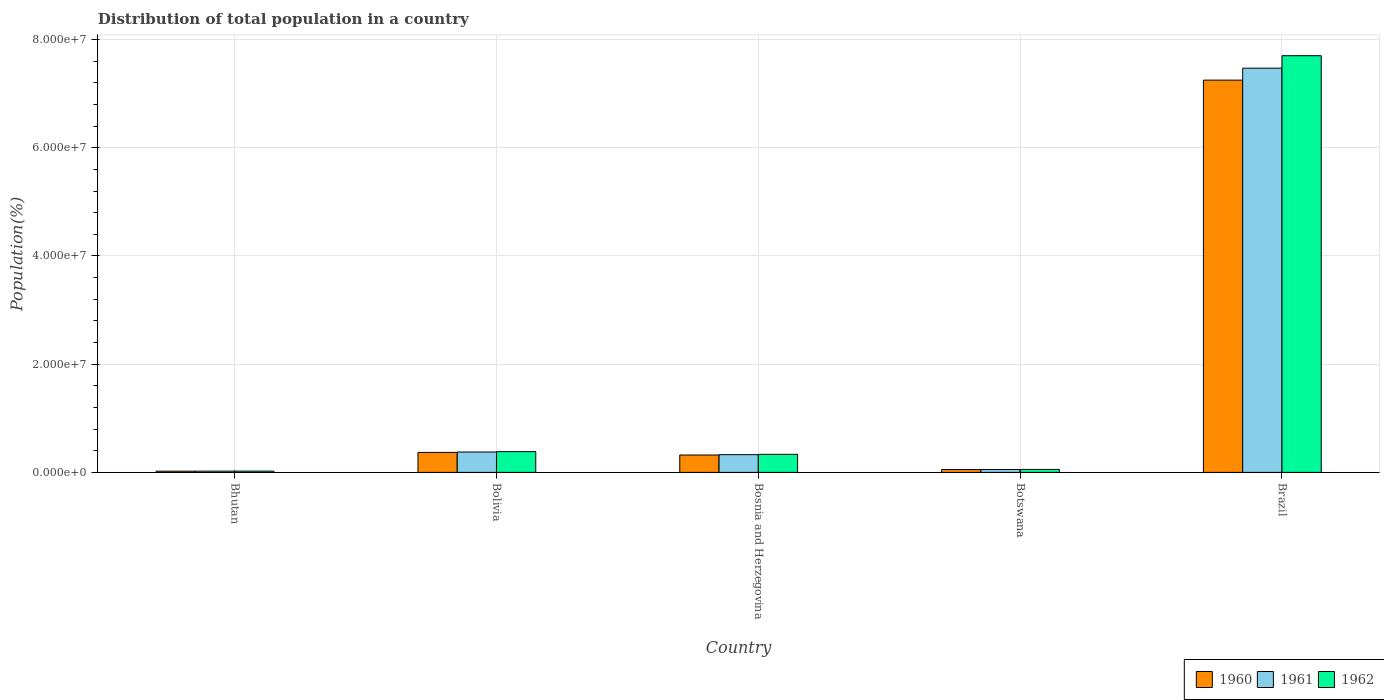How many groups of bars are there?
Provide a short and direct response. 5. What is the label of the 1st group of bars from the left?
Offer a very short reply. Bhutan. In how many cases, is the number of bars for a given country not equal to the number of legend labels?
Provide a succinct answer. 0. What is the population of in 1962 in Botswana?
Make the answer very short. 5.50e+05. Across all countries, what is the maximum population of in 1960?
Your answer should be very brief. 7.25e+07. Across all countries, what is the minimum population of in 1961?
Your answer should be compact. 2.29e+05. In which country was the population of in 1961 minimum?
Give a very brief answer. Bhutan. What is the total population of in 1960 in the graph?
Offer a very short reply. 8.01e+07. What is the difference between the population of in 1961 in Bosnia and Herzegovina and that in Botswana?
Your answer should be very brief. 2.74e+06. What is the difference between the population of in 1961 in Brazil and the population of in 1962 in Botswana?
Give a very brief answer. 7.42e+07. What is the average population of in 1961 per country?
Provide a succinct answer. 1.65e+07. What is the difference between the population of of/in 1962 and population of of/in 1961 in Bhutan?
Provide a succinct answer. 5406. In how many countries, is the population of in 1961 greater than 8000000 %?
Your answer should be very brief. 1. What is the ratio of the population of in 1960 in Bolivia to that in Brazil?
Your response must be concise. 0.05. Is the difference between the population of in 1962 in Bhutan and Bolivia greater than the difference between the population of in 1961 in Bhutan and Bolivia?
Your response must be concise. No. What is the difference between the highest and the second highest population of in 1961?
Your answer should be compact. 7.14e+07. What is the difference between the highest and the lowest population of in 1960?
Your answer should be compact. 7.23e+07. In how many countries, is the population of in 1962 greater than the average population of in 1962 taken over all countries?
Provide a succinct answer. 1. What does the 1st bar from the right in Bolivia represents?
Give a very brief answer. 1962. What is the difference between two consecutive major ticks on the Y-axis?
Provide a succinct answer. 2.00e+07. Are the values on the major ticks of Y-axis written in scientific E-notation?
Provide a short and direct response. Yes. How are the legend labels stacked?
Ensure brevity in your answer.  Horizontal. What is the title of the graph?
Offer a very short reply. Distribution of total population in a country. Does "1960" appear as one of the legend labels in the graph?
Offer a very short reply. Yes. What is the label or title of the Y-axis?
Give a very brief answer. Population(%). What is the Population(%) in 1960 in Bhutan?
Your answer should be compact. 2.24e+05. What is the Population(%) of 1961 in Bhutan?
Your response must be concise. 2.29e+05. What is the Population(%) in 1962 in Bhutan?
Your answer should be compact. 2.35e+05. What is the Population(%) of 1960 in Bolivia?
Provide a short and direct response. 3.69e+06. What is the Population(%) in 1961 in Bolivia?
Your answer should be compact. 3.76e+06. What is the Population(%) of 1962 in Bolivia?
Your answer should be compact. 3.84e+06. What is the Population(%) in 1960 in Bosnia and Herzegovina?
Your answer should be very brief. 3.21e+06. What is the Population(%) in 1961 in Bosnia and Herzegovina?
Offer a terse response. 3.28e+06. What is the Population(%) in 1962 in Bosnia and Herzegovina?
Keep it short and to the point. 3.34e+06. What is the Population(%) of 1960 in Botswana?
Your response must be concise. 5.24e+05. What is the Population(%) of 1961 in Botswana?
Give a very brief answer. 5.37e+05. What is the Population(%) in 1962 in Botswana?
Offer a terse response. 5.50e+05. What is the Population(%) in 1960 in Brazil?
Your response must be concise. 7.25e+07. What is the Population(%) in 1961 in Brazil?
Provide a short and direct response. 7.47e+07. What is the Population(%) in 1962 in Brazil?
Make the answer very short. 7.70e+07. Across all countries, what is the maximum Population(%) in 1960?
Offer a very short reply. 7.25e+07. Across all countries, what is the maximum Population(%) in 1961?
Give a very brief answer. 7.47e+07. Across all countries, what is the maximum Population(%) in 1962?
Make the answer very short. 7.70e+07. Across all countries, what is the minimum Population(%) in 1960?
Offer a very short reply. 2.24e+05. Across all countries, what is the minimum Population(%) of 1961?
Ensure brevity in your answer.  2.29e+05. Across all countries, what is the minimum Population(%) in 1962?
Provide a succinct answer. 2.35e+05. What is the total Population(%) in 1960 in the graph?
Make the answer very short. 8.01e+07. What is the total Population(%) in 1961 in the graph?
Offer a very short reply. 8.25e+07. What is the total Population(%) in 1962 in the graph?
Offer a terse response. 8.50e+07. What is the difference between the Population(%) of 1960 in Bhutan and that in Bolivia?
Keep it short and to the point. -3.47e+06. What is the difference between the Population(%) of 1961 in Bhutan and that in Bolivia?
Offer a terse response. -3.54e+06. What is the difference between the Population(%) in 1962 in Bhutan and that in Bolivia?
Your answer should be compact. -3.60e+06. What is the difference between the Population(%) of 1960 in Bhutan and that in Bosnia and Herzegovina?
Provide a short and direct response. -2.99e+06. What is the difference between the Population(%) in 1961 in Bhutan and that in Bosnia and Herzegovina?
Offer a terse response. -3.05e+06. What is the difference between the Population(%) of 1962 in Bhutan and that in Bosnia and Herzegovina?
Keep it short and to the point. -3.11e+06. What is the difference between the Population(%) of 1960 in Bhutan and that in Botswana?
Offer a very short reply. -3.00e+05. What is the difference between the Population(%) in 1961 in Bhutan and that in Botswana?
Offer a very short reply. -3.07e+05. What is the difference between the Population(%) in 1962 in Bhutan and that in Botswana?
Your answer should be compact. -3.15e+05. What is the difference between the Population(%) of 1960 in Bhutan and that in Brazil?
Your answer should be very brief. -7.23e+07. What is the difference between the Population(%) in 1961 in Bhutan and that in Brazil?
Keep it short and to the point. -7.45e+07. What is the difference between the Population(%) in 1962 in Bhutan and that in Brazil?
Offer a very short reply. -7.68e+07. What is the difference between the Population(%) in 1960 in Bolivia and that in Bosnia and Herzegovina?
Provide a succinct answer. 4.79e+05. What is the difference between the Population(%) of 1961 in Bolivia and that in Bosnia and Herzegovina?
Your response must be concise. 4.88e+05. What is the difference between the Population(%) of 1962 in Bolivia and that in Bosnia and Herzegovina?
Provide a short and direct response. 4.96e+05. What is the difference between the Population(%) of 1960 in Bolivia and that in Botswana?
Offer a terse response. 3.17e+06. What is the difference between the Population(%) of 1961 in Bolivia and that in Botswana?
Provide a succinct answer. 3.23e+06. What is the difference between the Population(%) of 1962 in Bolivia and that in Botswana?
Your answer should be very brief. 3.29e+06. What is the difference between the Population(%) of 1960 in Bolivia and that in Brazil?
Keep it short and to the point. -6.88e+07. What is the difference between the Population(%) in 1961 in Bolivia and that in Brazil?
Your answer should be compact. -7.09e+07. What is the difference between the Population(%) in 1962 in Bolivia and that in Brazil?
Give a very brief answer. -7.32e+07. What is the difference between the Population(%) in 1960 in Bosnia and Herzegovina and that in Botswana?
Offer a terse response. 2.69e+06. What is the difference between the Population(%) in 1961 in Bosnia and Herzegovina and that in Botswana?
Provide a short and direct response. 2.74e+06. What is the difference between the Population(%) in 1962 in Bosnia and Herzegovina and that in Botswana?
Make the answer very short. 2.79e+06. What is the difference between the Population(%) in 1960 in Bosnia and Herzegovina and that in Brazil?
Your answer should be compact. -6.93e+07. What is the difference between the Population(%) of 1961 in Bosnia and Herzegovina and that in Brazil?
Offer a terse response. -7.14e+07. What is the difference between the Population(%) in 1962 in Bosnia and Herzegovina and that in Brazil?
Provide a succinct answer. -7.37e+07. What is the difference between the Population(%) in 1960 in Botswana and that in Brazil?
Give a very brief answer. -7.20e+07. What is the difference between the Population(%) in 1961 in Botswana and that in Brazil?
Offer a very short reply. -7.42e+07. What is the difference between the Population(%) of 1962 in Botswana and that in Brazil?
Ensure brevity in your answer.  -7.65e+07. What is the difference between the Population(%) in 1960 in Bhutan and the Population(%) in 1961 in Bolivia?
Your answer should be very brief. -3.54e+06. What is the difference between the Population(%) in 1960 in Bhutan and the Population(%) in 1962 in Bolivia?
Offer a terse response. -3.61e+06. What is the difference between the Population(%) in 1961 in Bhutan and the Population(%) in 1962 in Bolivia?
Your answer should be very brief. -3.61e+06. What is the difference between the Population(%) in 1960 in Bhutan and the Population(%) in 1961 in Bosnia and Herzegovina?
Offer a terse response. -3.05e+06. What is the difference between the Population(%) of 1960 in Bhutan and the Population(%) of 1962 in Bosnia and Herzegovina?
Make the answer very short. -3.12e+06. What is the difference between the Population(%) in 1961 in Bhutan and the Population(%) in 1962 in Bosnia and Herzegovina?
Provide a succinct answer. -3.11e+06. What is the difference between the Population(%) of 1960 in Bhutan and the Population(%) of 1961 in Botswana?
Offer a very short reply. -3.12e+05. What is the difference between the Population(%) of 1960 in Bhutan and the Population(%) of 1962 in Botswana?
Offer a terse response. -3.26e+05. What is the difference between the Population(%) of 1961 in Bhutan and the Population(%) of 1962 in Botswana?
Offer a terse response. -3.21e+05. What is the difference between the Population(%) of 1960 in Bhutan and the Population(%) of 1961 in Brazil?
Give a very brief answer. -7.45e+07. What is the difference between the Population(%) of 1960 in Bhutan and the Population(%) of 1962 in Brazil?
Offer a terse response. -7.68e+07. What is the difference between the Population(%) of 1961 in Bhutan and the Population(%) of 1962 in Brazil?
Provide a short and direct response. -7.68e+07. What is the difference between the Population(%) of 1960 in Bolivia and the Population(%) of 1961 in Bosnia and Herzegovina?
Make the answer very short. 4.16e+05. What is the difference between the Population(%) in 1960 in Bolivia and the Population(%) in 1962 in Bosnia and Herzegovina?
Your answer should be very brief. 3.52e+05. What is the difference between the Population(%) of 1961 in Bolivia and the Population(%) of 1962 in Bosnia and Herzegovina?
Provide a succinct answer. 4.23e+05. What is the difference between the Population(%) in 1960 in Bolivia and the Population(%) in 1961 in Botswana?
Provide a succinct answer. 3.16e+06. What is the difference between the Population(%) in 1960 in Bolivia and the Population(%) in 1962 in Botswana?
Your response must be concise. 3.14e+06. What is the difference between the Population(%) in 1961 in Bolivia and the Population(%) in 1962 in Botswana?
Provide a short and direct response. 3.21e+06. What is the difference between the Population(%) in 1960 in Bolivia and the Population(%) in 1961 in Brazil?
Make the answer very short. -7.10e+07. What is the difference between the Population(%) in 1960 in Bolivia and the Population(%) in 1962 in Brazil?
Offer a terse response. -7.33e+07. What is the difference between the Population(%) in 1961 in Bolivia and the Population(%) in 1962 in Brazil?
Your answer should be very brief. -7.32e+07. What is the difference between the Population(%) in 1960 in Bosnia and Herzegovina and the Population(%) in 1961 in Botswana?
Your answer should be compact. 2.68e+06. What is the difference between the Population(%) in 1960 in Bosnia and Herzegovina and the Population(%) in 1962 in Botswana?
Offer a terse response. 2.66e+06. What is the difference between the Population(%) in 1961 in Bosnia and Herzegovina and the Population(%) in 1962 in Botswana?
Your response must be concise. 2.73e+06. What is the difference between the Population(%) in 1960 in Bosnia and Herzegovina and the Population(%) in 1961 in Brazil?
Ensure brevity in your answer.  -7.15e+07. What is the difference between the Population(%) in 1960 in Bosnia and Herzegovina and the Population(%) in 1962 in Brazil?
Ensure brevity in your answer.  -7.38e+07. What is the difference between the Population(%) in 1961 in Bosnia and Herzegovina and the Population(%) in 1962 in Brazil?
Make the answer very short. -7.37e+07. What is the difference between the Population(%) of 1960 in Botswana and the Population(%) of 1961 in Brazil?
Offer a very short reply. -7.42e+07. What is the difference between the Population(%) in 1960 in Botswana and the Population(%) in 1962 in Brazil?
Offer a terse response. -7.65e+07. What is the difference between the Population(%) in 1961 in Botswana and the Population(%) in 1962 in Brazil?
Ensure brevity in your answer.  -7.65e+07. What is the average Population(%) of 1960 per country?
Provide a short and direct response. 1.60e+07. What is the average Population(%) in 1961 per country?
Provide a succinct answer. 1.65e+07. What is the average Population(%) of 1962 per country?
Your answer should be compact. 1.70e+07. What is the difference between the Population(%) of 1960 and Population(%) of 1961 in Bhutan?
Keep it short and to the point. -5189. What is the difference between the Population(%) in 1960 and Population(%) in 1962 in Bhutan?
Keep it short and to the point. -1.06e+04. What is the difference between the Population(%) of 1961 and Population(%) of 1962 in Bhutan?
Make the answer very short. -5406. What is the difference between the Population(%) of 1960 and Population(%) of 1961 in Bolivia?
Keep it short and to the point. -7.14e+04. What is the difference between the Population(%) of 1960 and Population(%) of 1962 in Bolivia?
Offer a terse response. -1.45e+05. What is the difference between the Population(%) of 1961 and Population(%) of 1962 in Bolivia?
Ensure brevity in your answer.  -7.33e+04. What is the difference between the Population(%) in 1960 and Population(%) in 1961 in Bosnia and Herzegovina?
Make the answer very short. -6.26e+04. What is the difference between the Population(%) in 1960 and Population(%) in 1962 in Bosnia and Herzegovina?
Offer a terse response. -1.27e+05. What is the difference between the Population(%) of 1961 and Population(%) of 1962 in Bosnia and Herzegovina?
Keep it short and to the point. -6.47e+04. What is the difference between the Population(%) of 1960 and Population(%) of 1961 in Botswana?
Provide a short and direct response. -1.25e+04. What is the difference between the Population(%) in 1960 and Population(%) in 1962 in Botswana?
Offer a terse response. -2.60e+04. What is the difference between the Population(%) in 1961 and Population(%) in 1962 in Botswana?
Give a very brief answer. -1.34e+04. What is the difference between the Population(%) in 1960 and Population(%) in 1961 in Brazil?
Provide a succinct answer. -2.21e+06. What is the difference between the Population(%) in 1960 and Population(%) in 1962 in Brazil?
Offer a terse response. -4.51e+06. What is the difference between the Population(%) in 1961 and Population(%) in 1962 in Brazil?
Offer a very short reply. -2.30e+06. What is the ratio of the Population(%) of 1960 in Bhutan to that in Bolivia?
Offer a terse response. 0.06. What is the ratio of the Population(%) in 1961 in Bhutan to that in Bolivia?
Give a very brief answer. 0.06. What is the ratio of the Population(%) of 1962 in Bhutan to that in Bolivia?
Provide a short and direct response. 0.06. What is the ratio of the Population(%) of 1960 in Bhutan to that in Bosnia and Herzegovina?
Provide a succinct answer. 0.07. What is the ratio of the Population(%) in 1961 in Bhutan to that in Bosnia and Herzegovina?
Your response must be concise. 0.07. What is the ratio of the Population(%) in 1962 in Bhutan to that in Bosnia and Herzegovina?
Your answer should be very brief. 0.07. What is the ratio of the Population(%) in 1960 in Bhutan to that in Botswana?
Provide a succinct answer. 0.43. What is the ratio of the Population(%) in 1961 in Bhutan to that in Botswana?
Make the answer very short. 0.43. What is the ratio of the Population(%) in 1962 in Bhutan to that in Botswana?
Give a very brief answer. 0.43. What is the ratio of the Population(%) in 1960 in Bhutan to that in Brazil?
Your answer should be very brief. 0. What is the ratio of the Population(%) of 1961 in Bhutan to that in Brazil?
Provide a short and direct response. 0. What is the ratio of the Population(%) in 1962 in Bhutan to that in Brazil?
Provide a succinct answer. 0. What is the ratio of the Population(%) in 1960 in Bolivia to that in Bosnia and Herzegovina?
Provide a short and direct response. 1.15. What is the ratio of the Population(%) of 1961 in Bolivia to that in Bosnia and Herzegovina?
Keep it short and to the point. 1.15. What is the ratio of the Population(%) of 1962 in Bolivia to that in Bosnia and Herzegovina?
Your answer should be very brief. 1.15. What is the ratio of the Population(%) of 1960 in Bolivia to that in Botswana?
Your answer should be very brief. 7.05. What is the ratio of the Population(%) of 1961 in Bolivia to that in Botswana?
Provide a short and direct response. 7.02. What is the ratio of the Population(%) of 1962 in Bolivia to that in Botswana?
Provide a short and direct response. 6.98. What is the ratio of the Population(%) in 1960 in Bolivia to that in Brazil?
Keep it short and to the point. 0.05. What is the ratio of the Population(%) of 1961 in Bolivia to that in Brazil?
Ensure brevity in your answer.  0.05. What is the ratio of the Population(%) of 1962 in Bolivia to that in Brazil?
Your answer should be compact. 0.05. What is the ratio of the Population(%) in 1960 in Bosnia and Herzegovina to that in Botswana?
Provide a short and direct response. 6.13. What is the ratio of the Population(%) in 1961 in Bosnia and Herzegovina to that in Botswana?
Give a very brief answer. 6.11. What is the ratio of the Population(%) in 1962 in Bosnia and Herzegovina to that in Botswana?
Keep it short and to the point. 6.08. What is the ratio of the Population(%) in 1960 in Bosnia and Herzegovina to that in Brazil?
Your response must be concise. 0.04. What is the ratio of the Population(%) of 1961 in Bosnia and Herzegovina to that in Brazil?
Make the answer very short. 0.04. What is the ratio of the Population(%) of 1962 in Bosnia and Herzegovina to that in Brazil?
Provide a succinct answer. 0.04. What is the ratio of the Population(%) of 1960 in Botswana to that in Brazil?
Your answer should be very brief. 0.01. What is the ratio of the Population(%) of 1961 in Botswana to that in Brazil?
Your answer should be very brief. 0.01. What is the ratio of the Population(%) in 1962 in Botswana to that in Brazil?
Provide a short and direct response. 0.01. What is the difference between the highest and the second highest Population(%) of 1960?
Provide a short and direct response. 6.88e+07. What is the difference between the highest and the second highest Population(%) of 1961?
Give a very brief answer. 7.09e+07. What is the difference between the highest and the second highest Population(%) of 1962?
Offer a terse response. 7.32e+07. What is the difference between the highest and the lowest Population(%) of 1960?
Offer a very short reply. 7.23e+07. What is the difference between the highest and the lowest Population(%) in 1961?
Your answer should be very brief. 7.45e+07. What is the difference between the highest and the lowest Population(%) of 1962?
Offer a terse response. 7.68e+07. 